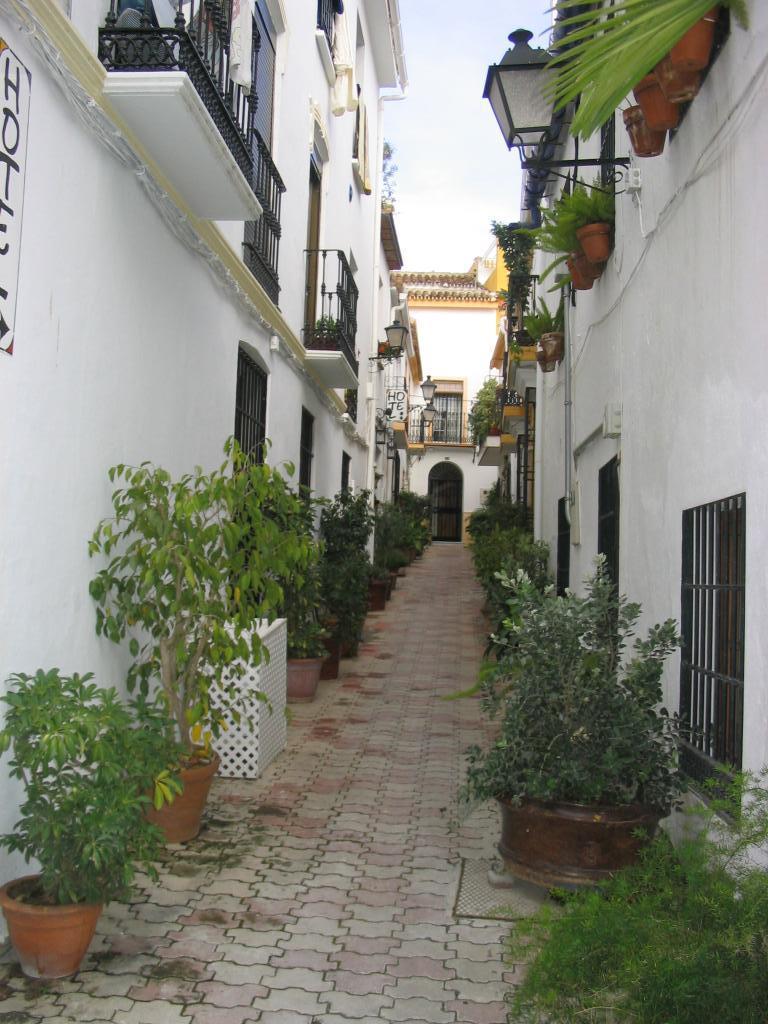Could you give a brief overview of what you see in this image? We can see plants with pots, buildings, lights, fences and windows. In the background we can see sky. 